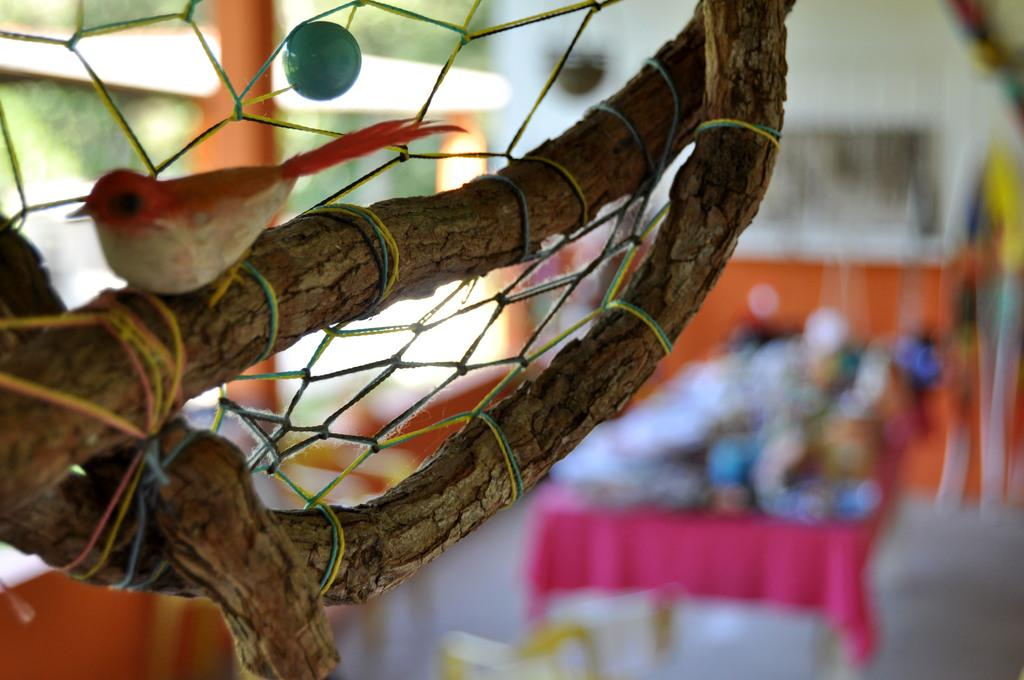What type of toy is in the image? There is a toy bird in the image. Where is the toy bird positioned? The toy bird is sitting on a tree branch. Can you describe the background of the image? The backdrop of the image is blurred. What type of wool can be seen on the table in the image? There is no table or wool present in the image; it features a toy bird sitting on a tree branch with a blurred backdrop. 